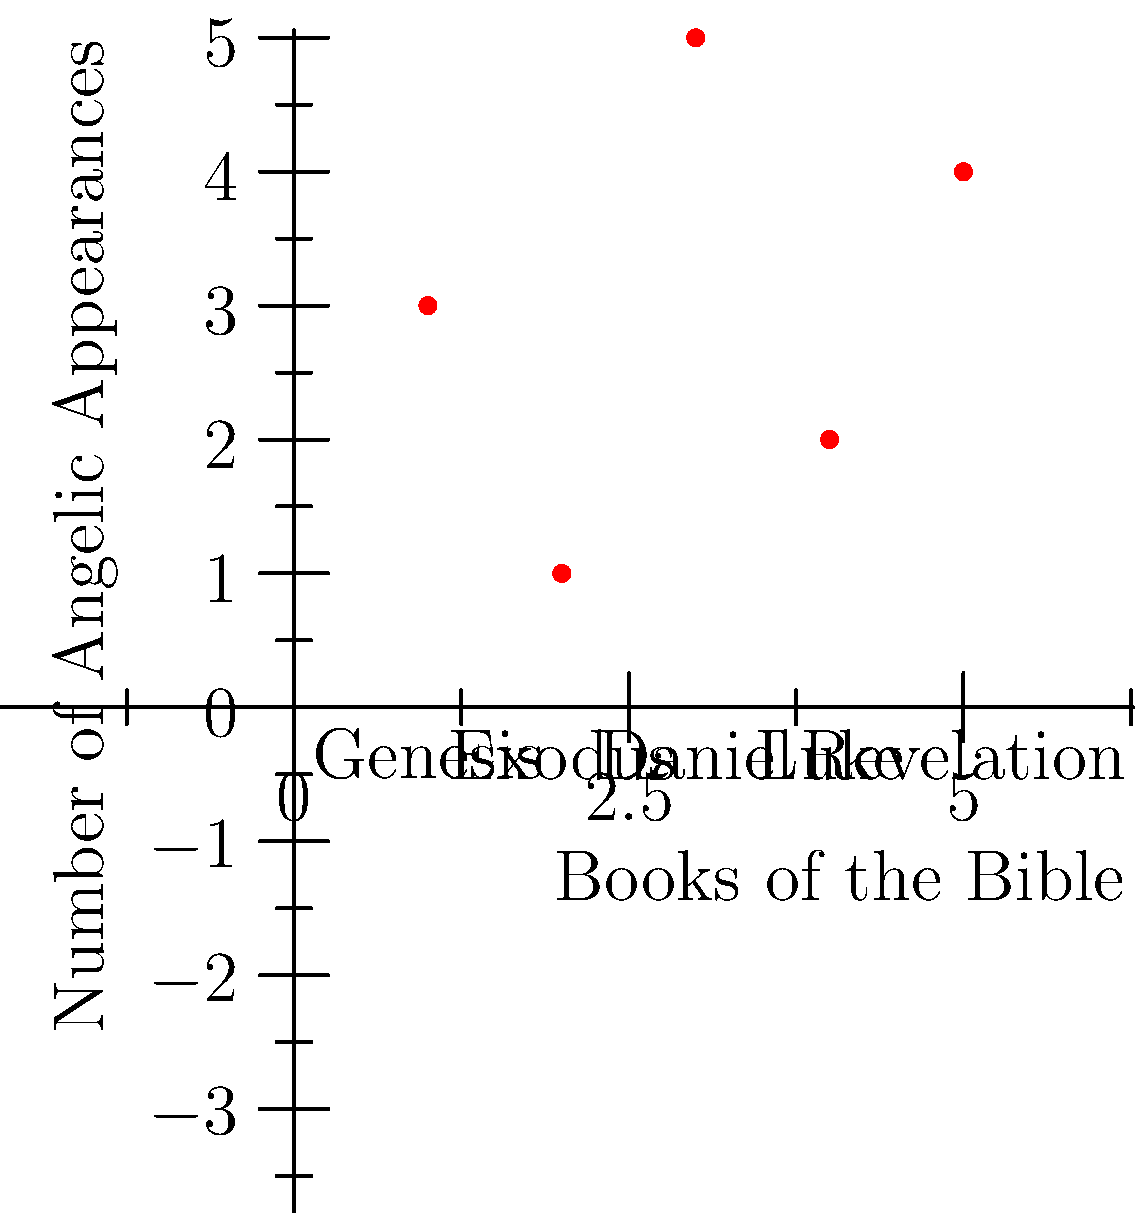In the given coordinate plane, angelic appearances in various books of the Bible are plotted. The x-axis represents different books, while the y-axis shows the number of angelic appearances. Which book has the highest number of recorded angelic appearances, and how many appearances are there? To answer this question, we need to analyze the graph and identify the point with the highest y-coordinate:

1. Genesis (x=1): 3 appearances
2. Exodus (x=2): 1 appearance
3. Daniel (x=3): 5 appearances
4. Luke (x=4): 2 appearances
5. Revelation (x=5): 4 appearances

The point with the highest y-coordinate is at (3,5), corresponding to the book of Daniel. This indicates that Daniel has the highest number of recorded angelic appearances among the books shown.

Therefore, the book with the highest number of angelic appearances is Daniel, with 5 appearances.
Answer: Daniel, 5 appearances 